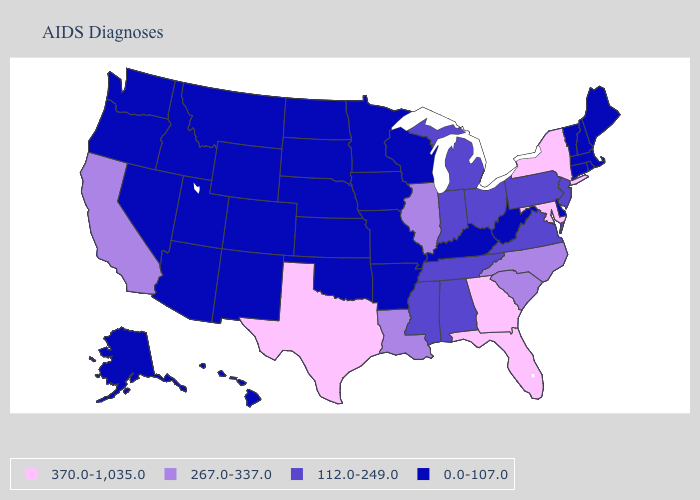What is the value of North Dakota?
Quick response, please. 0.0-107.0. What is the lowest value in states that border Utah?
Short answer required. 0.0-107.0. Name the states that have a value in the range 267.0-337.0?
Be succinct. California, Illinois, Louisiana, North Carolina, South Carolina. What is the value of Delaware?
Concise answer only. 0.0-107.0. Does Illinois have the highest value in the MidWest?
Write a very short answer. Yes. What is the lowest value in the West?
Write a very short answer. 0.0-107.0. Does Arkansas have the lowest value in the South?
Write a very short answer. Yes. How many symbols are there in the legend?
Short answer required. 4. Name the states that have a value in the range 267.0-337.0?
Answer briefly. California, Illinois, Louisiana, North Carolina, South Carolina. Name the states that have a value in the range 267.0-337.0?
Short answer required. California, Illinois, Louisiana, North Carolina, South Carolina. What is the value of Washington?
Be succinct. 0.0-107.0. What is the value of Vermont?
Quick response, please. 0.0-107.0. Name the states that have a value in the range 267.0-337.0?
Give a very brief answer. California, Illinois, Louisiana, North Carolina, South Carolina. Name the states that have a value in the range 112.0-249.0?
Answer briefly. Alabama, Indiana, Michigan, Mississippi, New Jersey, Ohio, Pennsylvania, Tennessee, Virginia. 